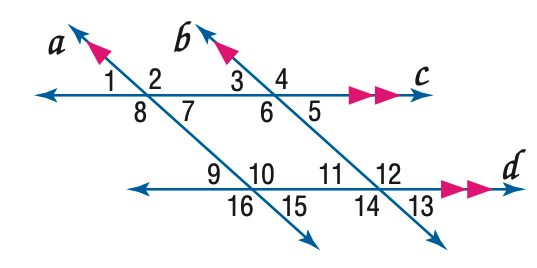Answer the mathemtical geometry problem and directly provide the correct option letter.
Question: In the figure, m \angle 3 = 43. Find the measure of \angle 13.
Choices: A: 33 B: 43 C: 53 D: 63 B 